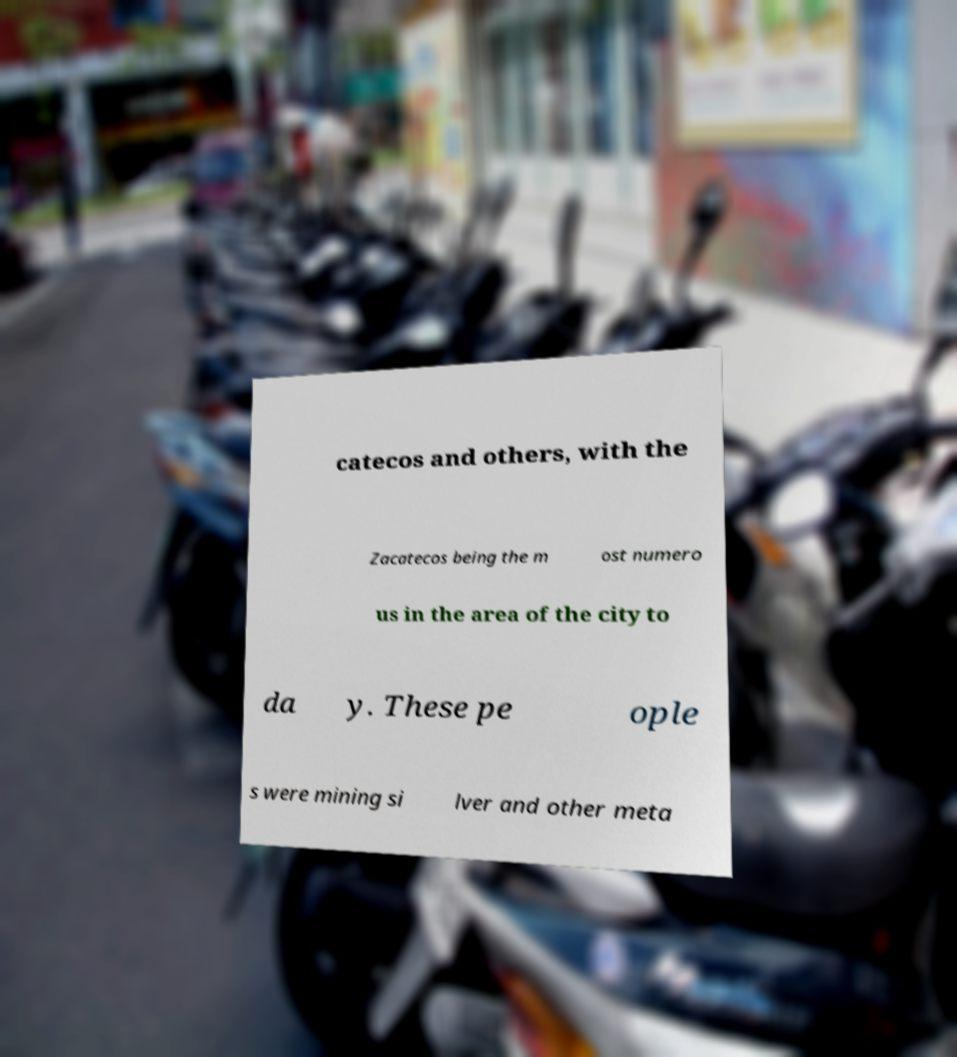Could you extract and type out the text from this image? catecos and others, with the Zacatecos being the m ost numero us in the area of the city to da y. These pe ople s were mining si lver and other meta 